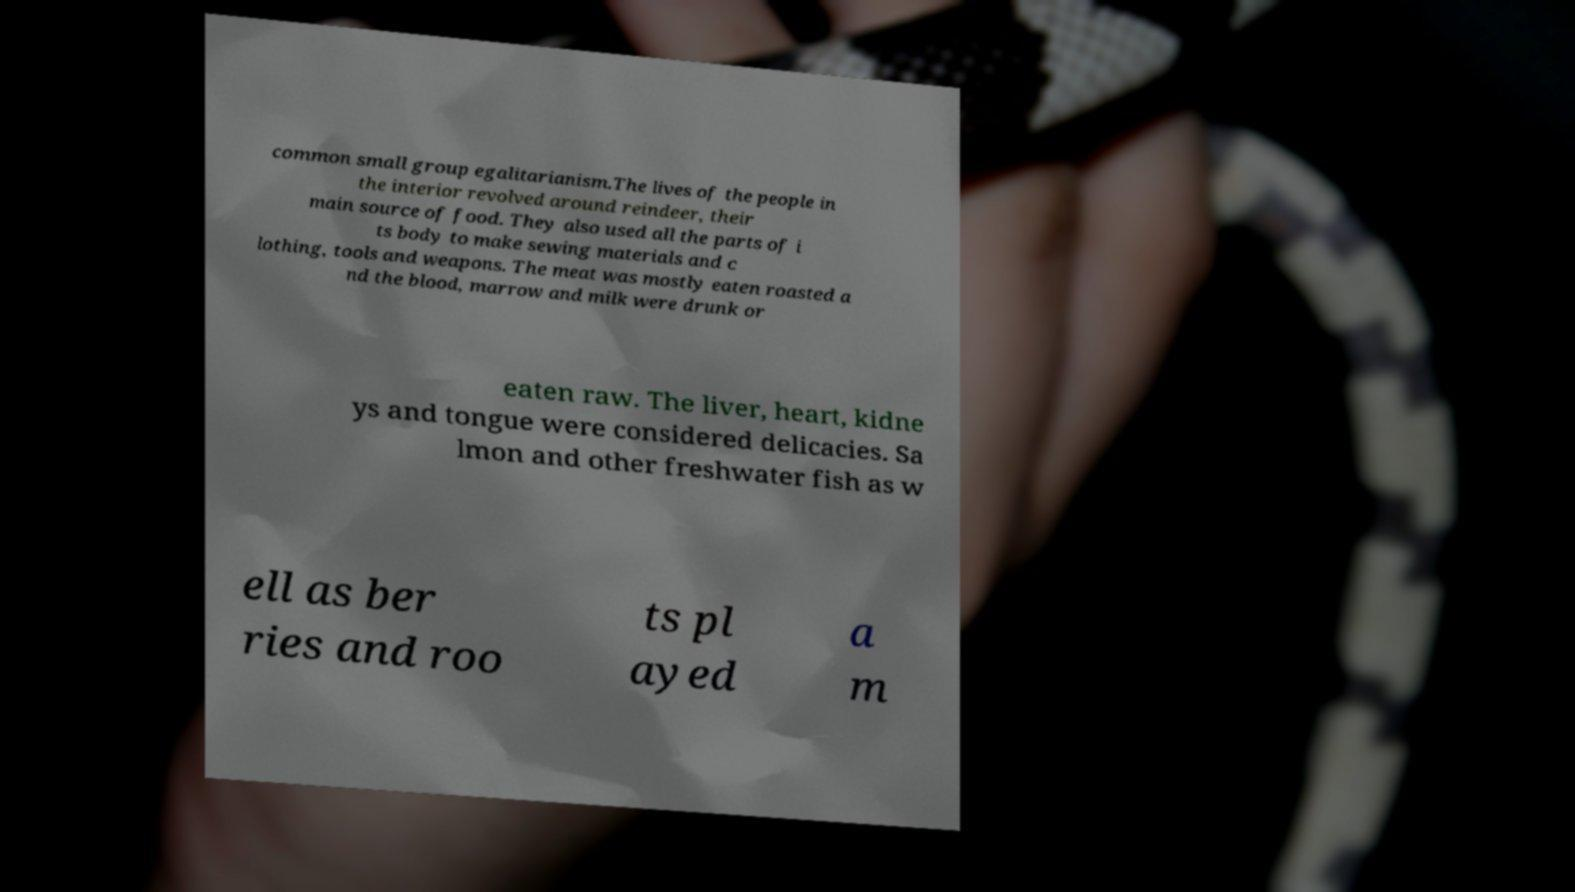I need the written content from this picture converted into text. Can you do that? common small group egalitarianism.The lives of the people in the interior revolved around reindeer, their main source of food. They also used all the parts of i ts body to make sewing materials and c lothing, tools and weapons. The meat was mostly eaten roasted a nd the blood, marrow and milk were drunk or eaten raw. The liver, heart, kidne ys and tongue were considered delicacies. Sa lmon and other freshwater fish as w ell as ber ries and roo ts pl ayed a m 